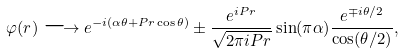<formula> <loc_0><loc_0><loc_500><loc_500>\varphi ( r ) \longrightarrow e ^ { - i ( \alpha \theta + P r \cos \theta ) } \pm \frac { e ^ { i P r } } { \sqrt { 2 \pi i P r } } \sin ( \pi \alpha ) \frac { e ^ { \mp i \theta / 2 } } { \cos ( \theta / 2 ) } ,</formula> 